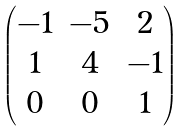<formula> <loc_0><loc_0><loc_500><loc_500>\begin{pmatrix} - 1 & - 5 & 2 \\ 1 & 4 & - 1 \\ 0 & 0 & 1 \end{pmatrix}</formula> 